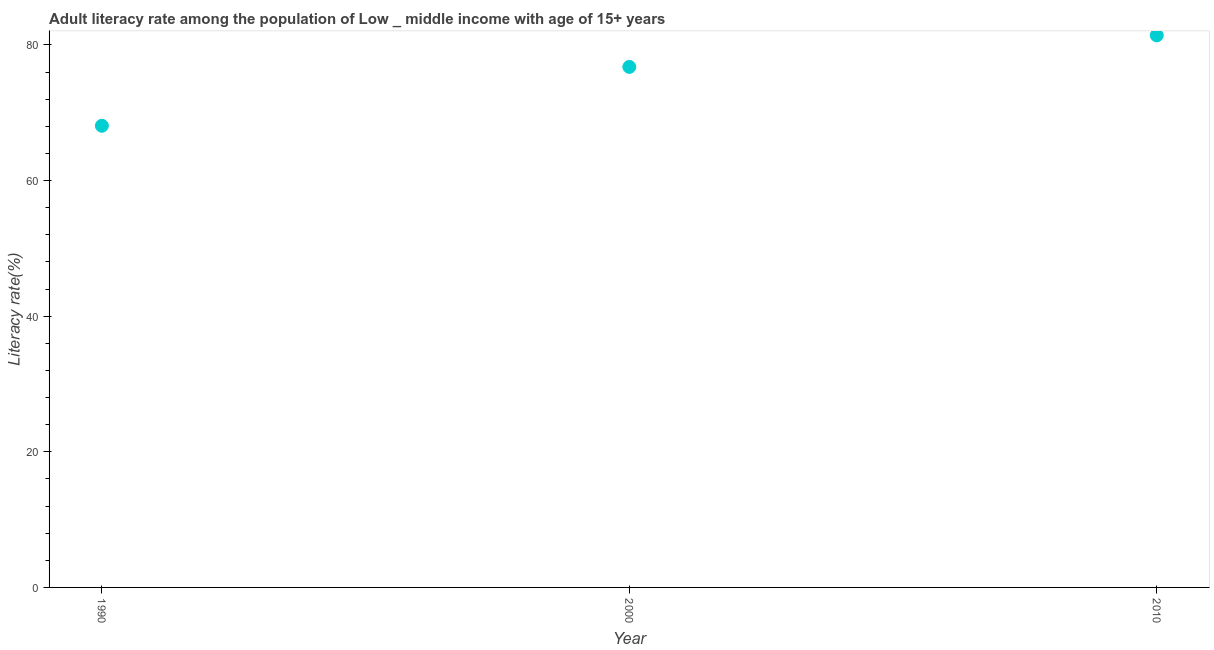What is the adult literacy rate in 1990?
Provide a short and direct response. 68.08. Across all years, what is the maximum adult literacy rate?
Your answer should be compact. 81.41. Across all years, what is the minimum adult literacy rate?
Provide a short and direct response. 68.08. In which year was the adult literacy rate maximum?
Offer a very short reply. 2010. What is the sum of the adult literacy rate?
Your answer should be compact. 226.24. What is the difference between the adult literacy rate in 2000 and 2010?
Your answer should be compact. -4.65. What is the average adult literacy rate per year?
Ensure brevity in your answer.  75.41. What is the median adult literacy rate?
Offer a terse response. 76.76. In how many years, is the adult literacy rate greater than 8 %?
Your answer should be compact. 3. What is the ratio of the adult literacy rate in 1990 to that in 2000?
Ensure brevity in your answer.  0.89. Is the difference between the adult literacy rate in 1990 and 2000 greater than the difference between any two years?
Ensure brevity in your answer.  No. What is the difference between the highest and the second highest adult literacy rate?
Provide a short and direct response. 4.65. Is the sum of the adult literacy rate in 1990 and 2010 greater than the maximum adult literacy rate across all years?
Make the answer very short. Yes. What is the difference between the highest and the lowest adult literacy rate?
Your response must be concise. 13.33. In how many years, is the adult literacy rate greater than the average adult literacy rate taken over all years?
Make the answer very short. 2. Does the adult literacy rate monotonically increase over the years?
Make the answer very short. Yes. What is the difference between two consecutive major ticks on the Y-axis?
Offer a very short reply. 20. What is the title of the graph?
Ensure brevity in your answer.  Adult literacy rate among the population of Low _ middle income with age of 15+ years. What is the label or title of the X-axis?
Make the answer very short. Year. What is the label or title of the Y-axis?
Offer a very short reply. Literacy rate(%). What is the Literacy rate(%) in 1990?
Your answer should be very brief. 68.08. What is the Literacy rate(%) in 2000?
Give a very brief answer. 76.76. What is the Literacy rate(%) in 2010?
Your answer should be compact. 81.41. What is the difference between the Literacy rate(%) in 1990 and 2000?
Your answer should be very brief. -8.68. What is the difference between the Literacy rate(%) in 1990 and 2010?
Provide a succinct answer. -13.33. What is the difference between the Literacy rate(%) in 2000 and 2010?
Make the answer very short. -4.65. What is the ratio of the Literacy rate(%) in 1990 to that in 2000?
Offer a very short reply. 0.89. What is the ratio of the Literacy rate(%) in 1990 to that in 2010?
Offer a very short reply. 0.84. What is the ratio of the Literacy rate(%) in 2000 to that in 2010?
Keep it short and to the point. 0.94. 